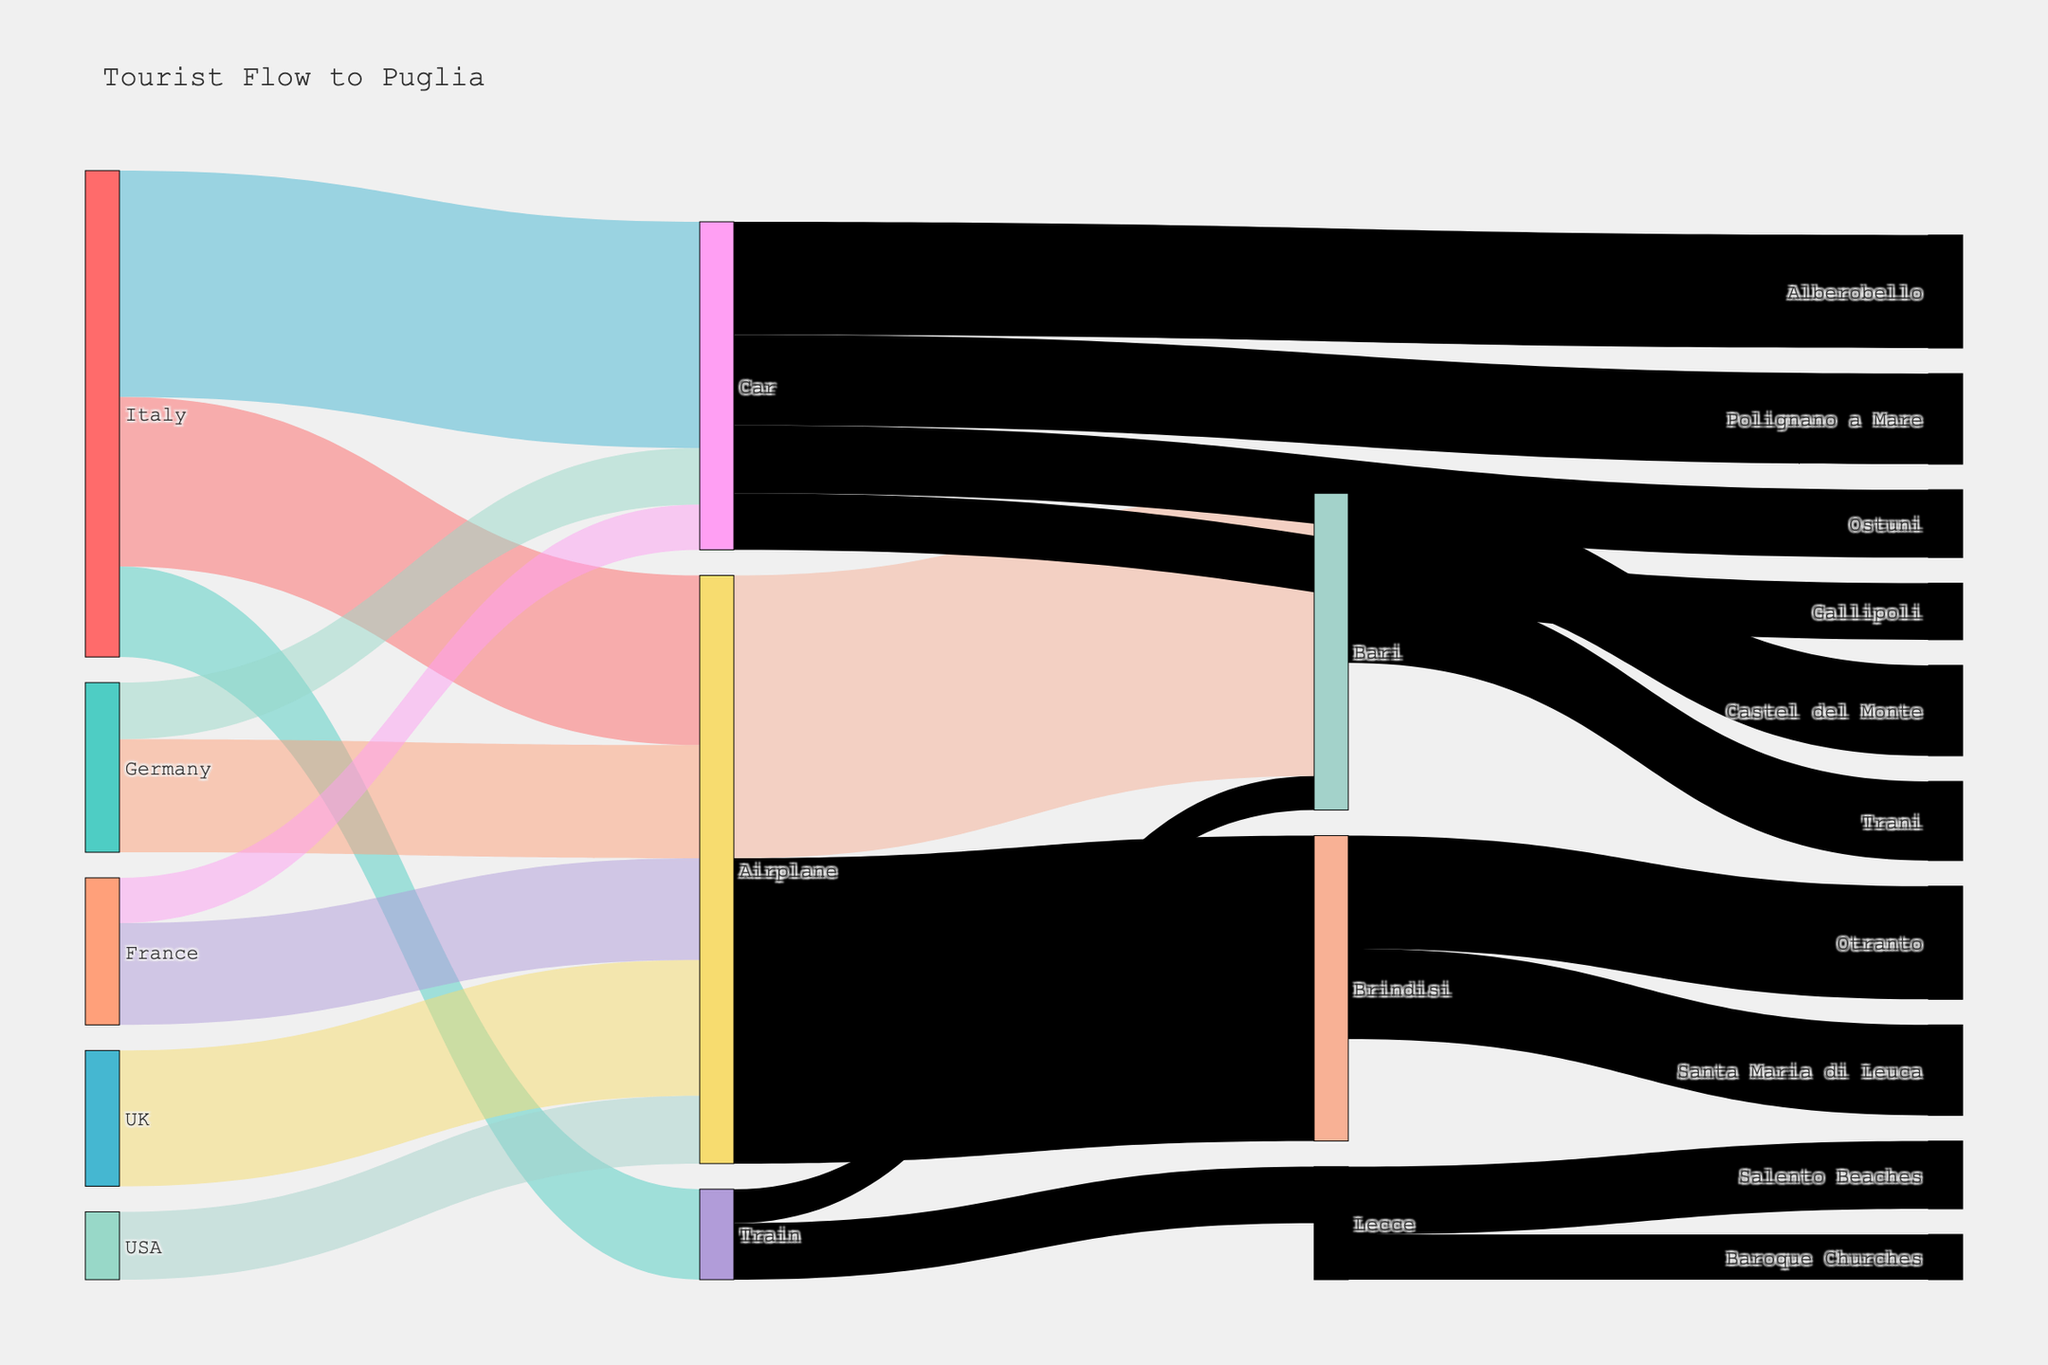What is the highest number of tourists traveling to Puglia by plane from a single country? To find this, we look at the sources connected to Airplane. Italy contributes 150,000, Germany 100,000, UK 120,000, France 90,000, and USA 60,000. The maximum is hence 150,000 from Italy.
Answer: 150,000 How many tourists visit Bari by plane? To find this, we look at the value of tourists traveling from "Airplane" to "Bari," which is 250,000.
Answer: 250,000 Which destination receives the largest number of tourists via car? Check the values of tourists traveling by "Car" to each destination. Alberobello receives 100,000, Polignano a Mare 80,000, Ostuni 60,000, and Gallipoli 50,000. The highest number is 100,000 for Alberobello.
Answer: Alberobello How many tourists travel from Italy to Puglia in total across all modes of transportation? Sum the values for Italy as the source with all transport modes: Airplane (150,000), Train (80,000), and Car (200,000). The sum is 150,000 + 80,000 + 200,000 = 430,000.
Answer: 430,000 What is the total number of tourists visiting Brindisi? Add the tourists visiting Brindisi from the modes of transportation: Airplane (270,000) and those continuing to Otranto (100,000) and Santa Maria di Leuca (80,000). The total is 270,000 + 100,000 + 80,000 = 450,000.
Answer: 450,000 Who are the visitors to Lecce and what are their primary activities? From the diagram, tourists reach Lecce by Train (50,000) and visit Baroque Churches (40,000) or Salento Beaches (60,000).
Answer: Train (50,000); Baroque Churches (40,000), Salento Beaches (60,000) What is the difference in tourist arrivals between Bari and Brindisi from airplanes? Look at the values going from Airplane to Bari (250,000) and Brindisi (270,000). The difference is 270,000 - 250,000 = 20,000.
Answer: 20,000 Which country sends the most tourists to Puglia by car? Check the connections of "Car" with various countries. Italy sends 200,000 and Germany 50,000. Italy has the highest at 200,000.
Answer: Italy How many destinations in Puglia do tourists visit after arriving by airplane? Count the unique destinations tourists visit after arriving by airplane. Bari (250,000) and Brindisi (270,000) are the destinations listed. There are two unique destinations.
Answer: Two What is the total number of tourists visiting Ostuni and Gallipoli combined, traveling by car? Add the tourists traveling by "Car" to Ostuni (60,000) and Gallipoli (50,000). The combined total is 60,000 + 50,000 = 110,000.
Answer: 110,000 